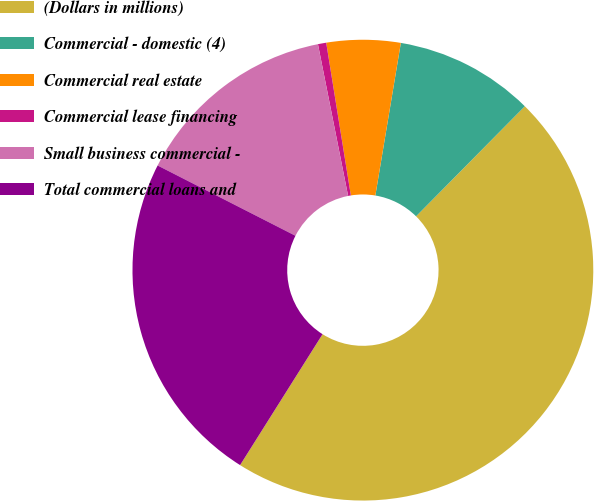Convert chart. <chart><loc_0><loc_0><loc_500><loc_500><pie_chart><fcel>(Dollars in millions)<fcel>Commercial - domestic (4)<fcel>Commercial real estate<fcel>Commercial lease financing<fcel>Small business commercial -<fcel>Total commercial loans and<nl><fcel>46.54%<fcel>9.77%<fcel>5.18%<fcel>0.58%<fcel>14.37%<fcel>23.56%<nl></chart> 